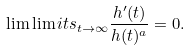Convert formula to latex. <formula><loc_0><loc_0><loc_500><loc_500>\lim \lim i t s _ { t \to \infty } \frac { h ^ { \prime } ( t ) } { h ( t ) ^ { a } } = 0 .</formula> 